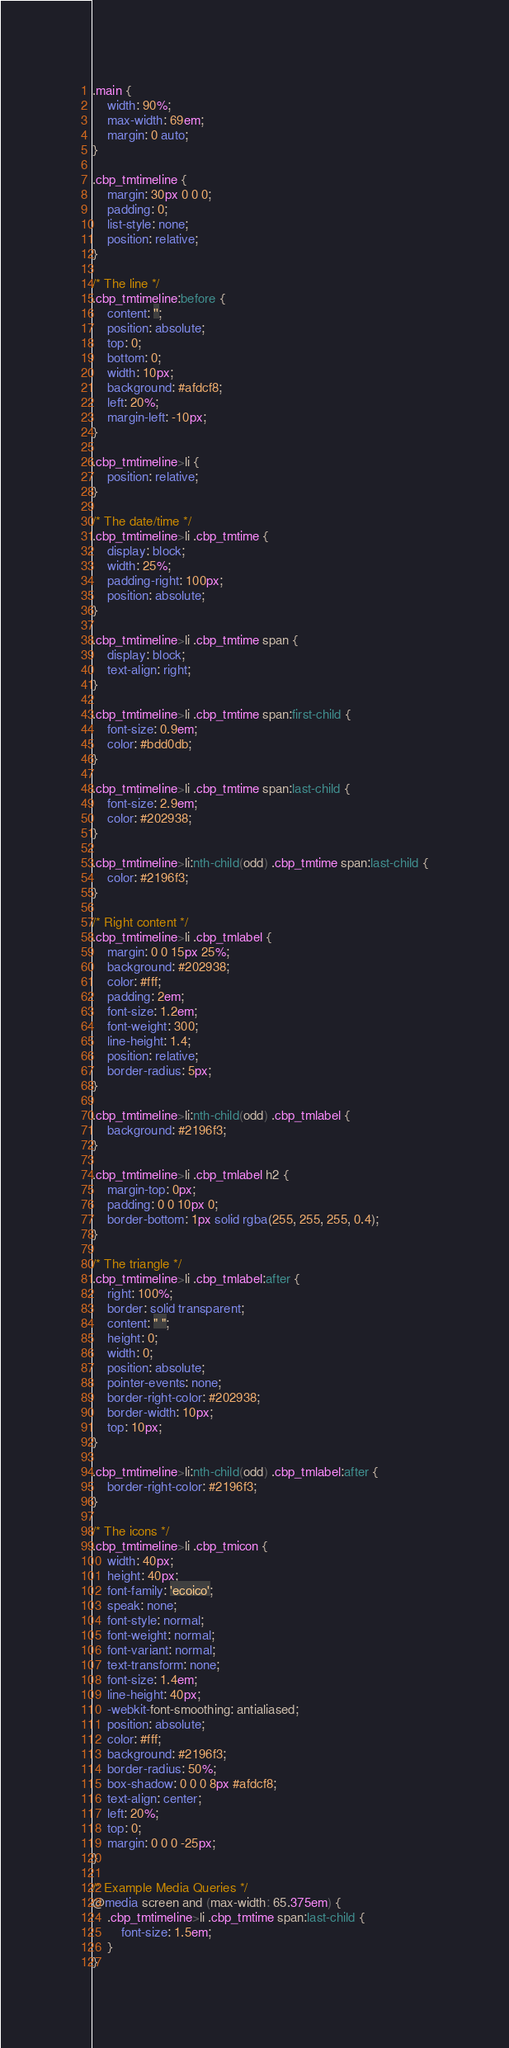Convert code to text. <code><loc_0><loc_0><loc_500><loc_500><_CSS_>.main {
    width: 90%;
    max-width: 69em;
    margin: 0 auto;
}

.cbp_tmtimeline {
    margin: 30px 0 0 0;
    padding: 0;
    list-style: none;
    position: relative;
}

/* The line */
.cbp_tmtimeline:before {
    content: '';
    position: absolute;
    top: 0;
    bottom: 0;
    width: 10px;
    background: #afdcf8;
    left: 20%;
    margin-left: -10px;
}

.cbp_tmtimeline>li {
    position: relative;
}

/* The date/time */
.cbp_tmtimeline>li .cbp_tmtime {
    display: block;
    width: 25%;
    padding-right: 100px;
    position: absolute;
}

.cbp_tmtimeline>li .cbp_tmtime span {
    display: block;
    text-align: right;
}

.cbp_tmtimeline>li .cbp_tmtime span:first-child {
    font-size: 0.9em;
    color: #bdd0db;
}

.cbp_tmtimeline>li .cbp_tmtime span:last-child {
    font-size: 2.9em;
    color: #202938;
}

.cbp_tmtimeline>li:nth-child(odd) .cbp_tmtime span:last-child {
    color: #2196f3;
}

/* Right content */
.cbp_tmtimeline>li .cbp_tmlabel {
    margin: 0 0 15px 25%;
    background: #202938;
    color: #fff;
    padding: 2em;
    font-size: 1.2em;
    font-weight: 300;
    line-height: 1.4;
    position: relative;
    border-radius: 5px;
}

.cbp_tmtimeline>li:nth-child(odd) .cbp_tmlabel {
    background: #2196f3;
}

.cbp_tmtimeline>li .cbp_tmlabel h2 {
    margin-top: 0px;
    padding: 0 0 10px 0;
    border-bottom: 1px solid rgba(255, 255, 255, 0.4);
}

/* The triangle */
.cbp_tmtimeline>li .cbp_tmlabel:after {
    right: 100%;
    border: solid transparent;
    content: " ";
    height: 0;
    width: 0;
    position: absolute;
    pointer-events: none;
    border-right-color: #202938;
    border-width: 10px;
    top: 10px;
}

.cbp_tmtimeline>li:nth-child(odd) .cbp_tmlabel:after {
    border-right-color: #2196f3;
}

/* The icons */
.cbp_tmtimeline>li .cbp_tmicon {
    width: 40px;
    height: 40px;
    font-family: 'ecoico';
    speak: none;
    font-style: normal;
    font-weight: normal;
    font-variant: normal;
    text-transform: none;
    font-size: 1.4em;
    line-height: 40px;
    -webkit-font-smoothing: antialiased;
    position: absolute;
    color: #fff;
    background: #2196f3;
    border-radius: 50%;
    box-shadow: 0 0 0 8px #afdcf8;
    text-align: center;
    left: 20%;
    top: 0;
    margin: 0 0 0 -25px;
}

/* Example Media Queries */
@media screen and (max-width: 65.375em) {
    .cbp_tmtimeline>li .cbp_tmtime span:last-child {
        font-size: 1.5em;
    }
}
</code> 